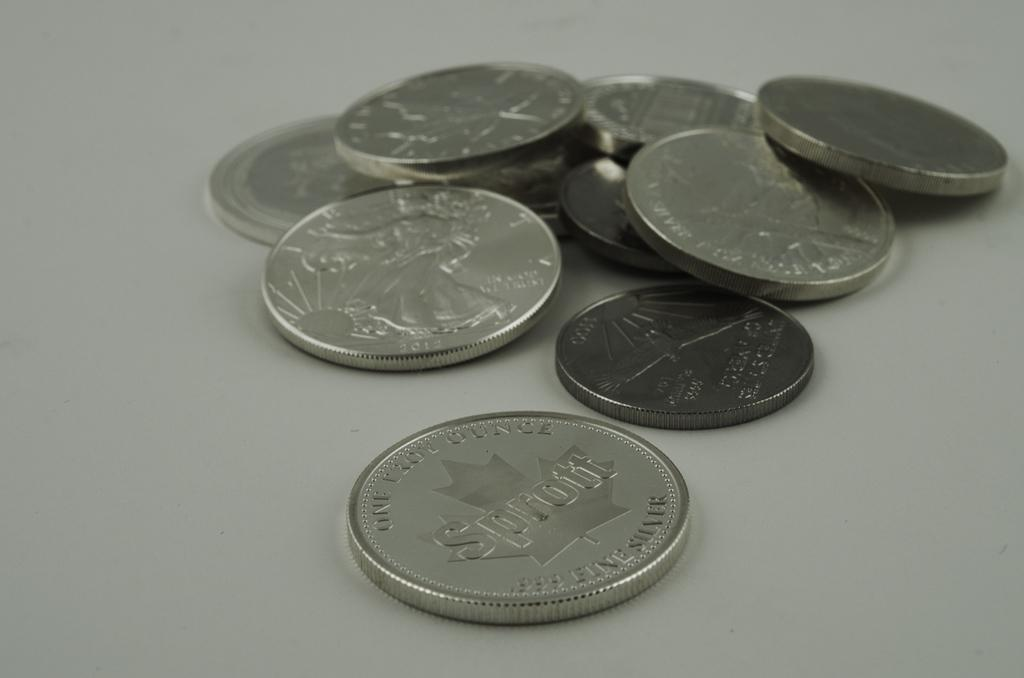<image>
Summarize the visual content of the image. A pile of coins, with the one in the middle reading One Troy Ounce, .999 Fine Silver on the edge and Sprout in the middle. 